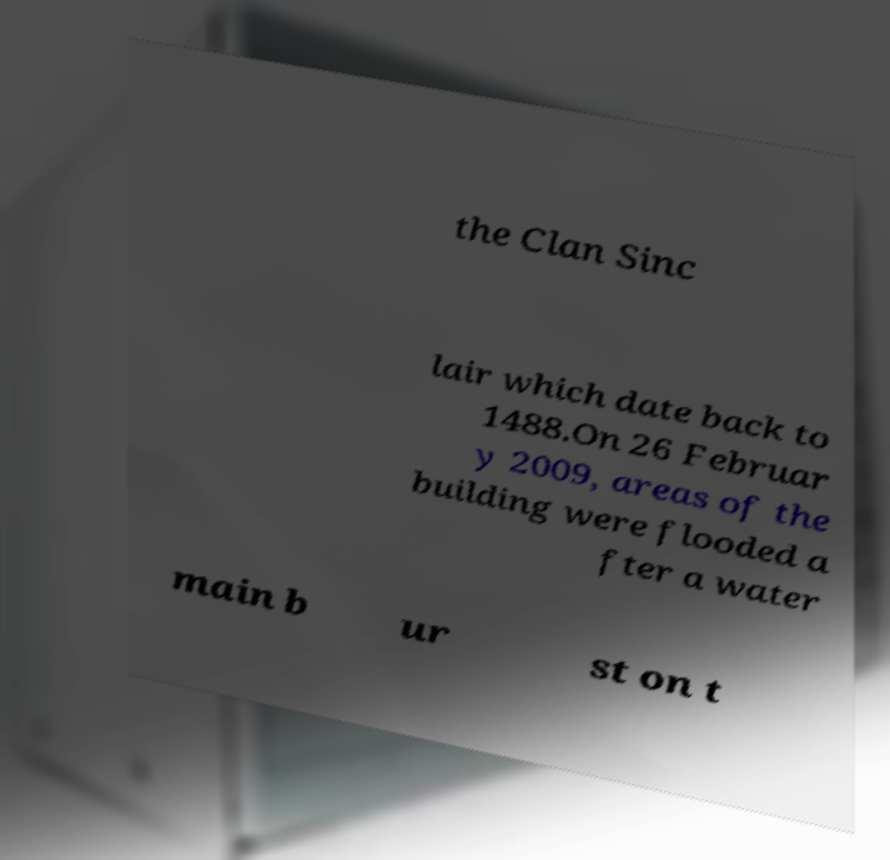Can you accurately transcribe the text from the provided image for me? the Clan Sinc lair which date back to 1488.On 26 Februar y 2009, areas of the building were flooded a fter a water main b ur st on t 